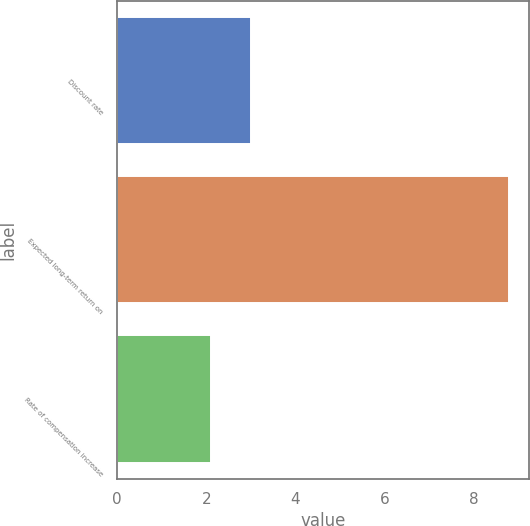Convert chart to OTSL. <chart><loc_0><loc_0><loc_500><loc_500><bar_chart><fcel>Discount rate<fcel>Expected long-term return on<fcel>Rate of compensation increase<nl><fcel>3<fcel>8.8<fcel>2.1<nl></chart> 